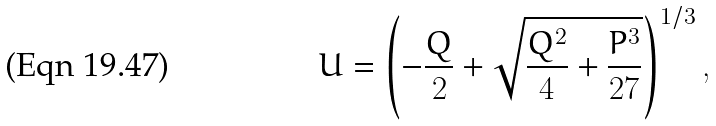Convert formula to latex. <formula><loc_0><loc_0><loc_500><loc_500>U = \left ( - \frac { Q } { 2 } + \sqrt { \frac { Q ^ { 2 } } { 4 } + \frac { P ^ { 3 } } { 2 7 } } \right ) ^ { 1 / 3 } ,</formula> 